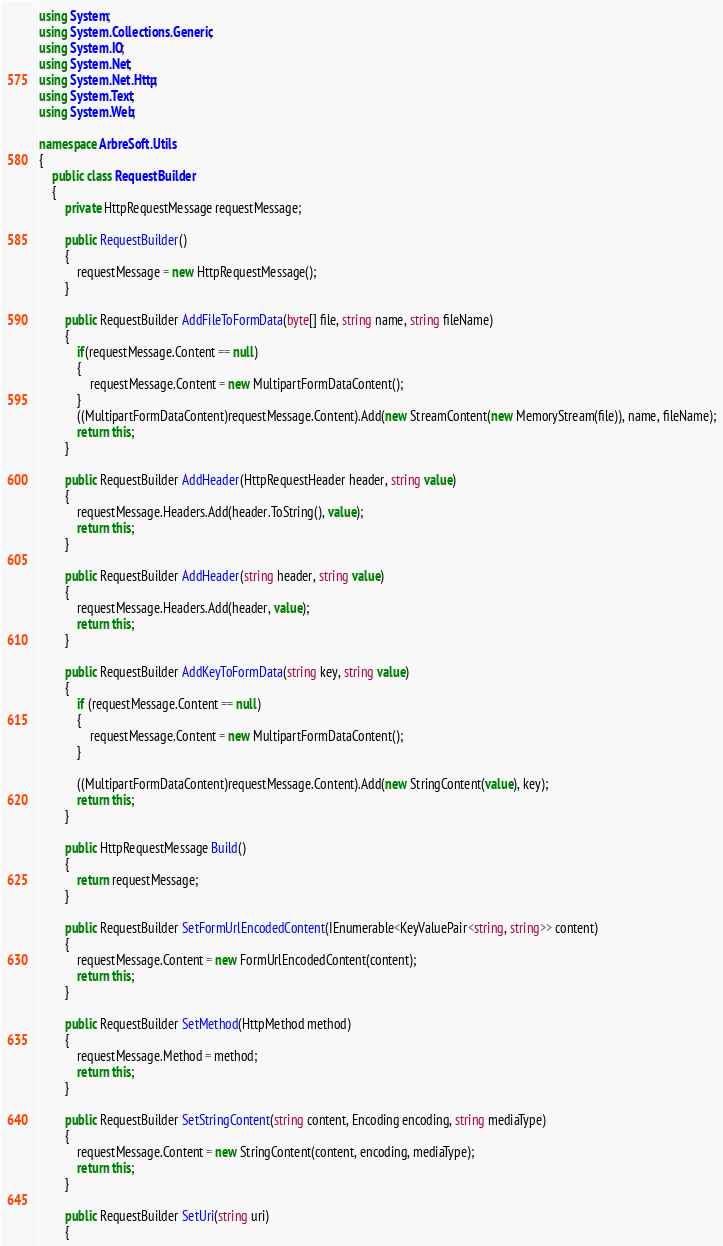<code> <loc_0><loc_0><loc_500><loc_500><_C#_>using System;
using System.Collections.Generic;
using System.IO;
using System.Net;
using System.Net.Http;
using System.Text;
using System.Web;

namespace ArbreSoft.Utils
{
    public class RequestBuilder
    {
        private HttpRequestMessage requestMessage;

        public RequestBuilder()
        {
            requestMessage = new HttpRequestMessage();
        }

        public RequestBuilder AddFileToFormData(byte[] file, string name, string fileName)
        {
            if(requestMessage.Content == null)
            {
                requestMessage.Content = new MultipartFormDataContent();
            }
            ((MultipartFormDataContent)requestMessage.Content).Add(new StreamContent(new MemoryStream(file)), name, fileName);
            return this;
        }

        public RequestBuilder AddHeader(HttpRequestHeader header, string value)
        {
            requestMessage.Headers.Add(header.ToString(), value);
            return this;
        }

        public RequestBuilder AddHeader(string header, string value)
        {
            requestMessage.Headers.Add(header, value);
            return this;
        }

        public RequestBuilder AddKeyToFormData(string key, string value)
        {
            if (requestMessage.Content == null)
            {
                requestMessage.Content = new MultipartFormDataContent();
            }

            ((MultipartFormDataContent)requestMessage.Content).Add(new StringContent(value), key); 
            return this;
        }

        public HttpRequestMessage Build()
        {
            return requestMessage;
        }

        public RequestBuilder SetFormUrlEncodedContent(IEnumerable<KeyValuePair<string, string>> content)
        {
            requestMessage.Content = new FormUrlEncodedContent(content);
            return this;
        }
        
        public RequestBuilder SetMethod(HttpMethod method)
        {
            requestMessage.Method = method;
            return this;
        }

        public RequestBuilder SetStringContent(string content, Encoding encoding, string mediaType)
        {
            requestMessage.Content = new StringContent(content, encoding, mediaType);
            return this;
        }
        
        public RequestBuilder SetUri(string uri)
        {</code> 